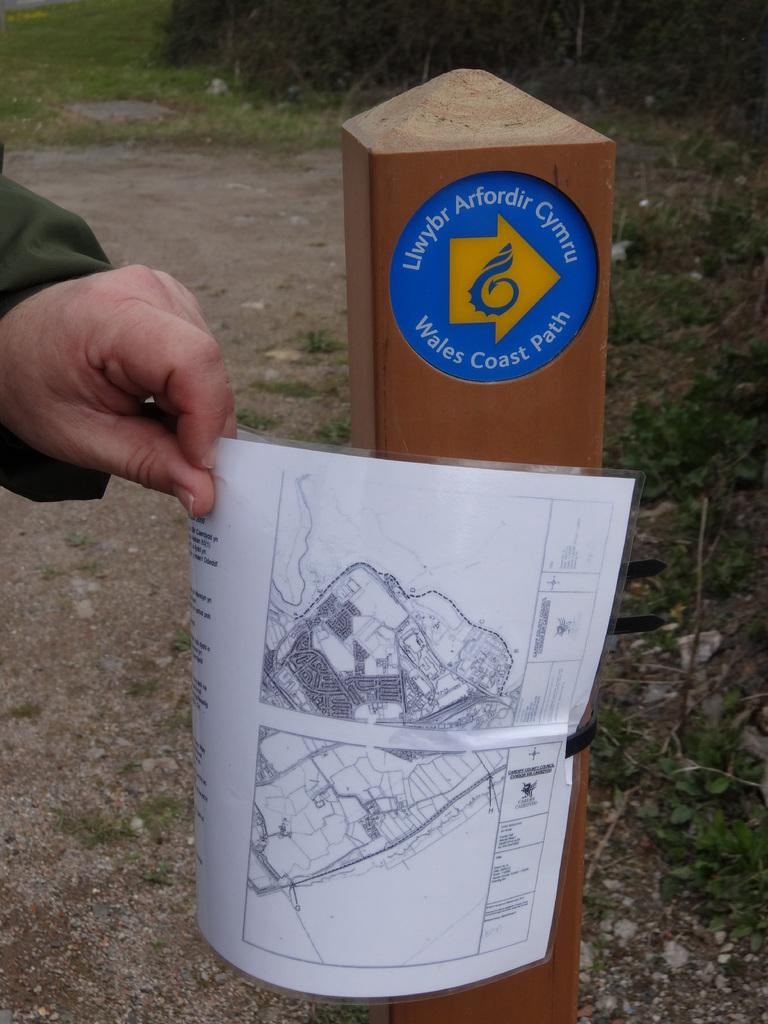What is the person holding in the image? There is a hand holding a paper in the image. What other object can be seen in the image? There is a wooden stick in the image. What type of natural environment is visible in the background of the image? There is grass visible in the background of the image. How many planes are flying over the grass in the image? There are no planes visible in the image; it only features a hand holding a paper, a wooden stick, and grass in the background. 